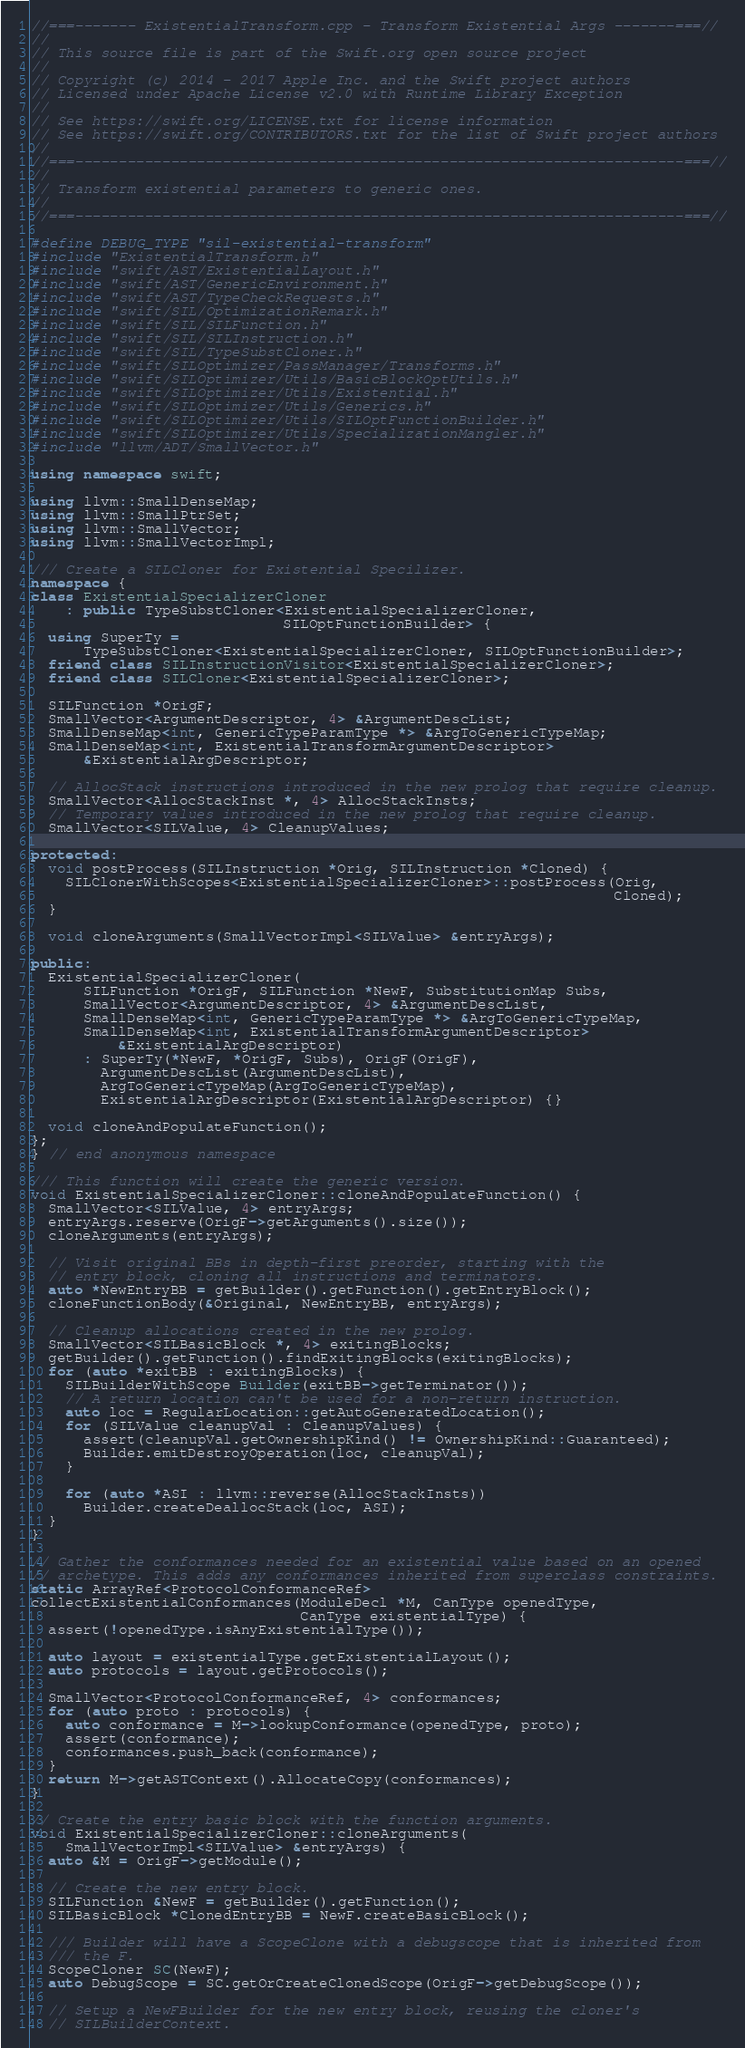<code> <loc_0><loc_0><loc_500><loc_500><_C++_>//===------- ExistentialTransform.cpp - Transform Existential Args -------===//
//
// This source file is part of the Swift.org open source project
//
// Copyright (c) 2014 - 2017 Apple Inc. and the Swift project authors
// Licensed under Apache License v2.0 with Runtime Library Exception
//
// See https://swift.org/LICENSE.txt for license information
// See https://swift.org/CONTRIBUTORS.txt for the list of Swift project authors
//
//===----------------------------------------------------------------------===//
//
// Transform existential parameters to generic ones.
//
//===----------------------------------------------------------------------===//

#define DEBUG_TYPE "sil-existential-transform"
#include "ExistentialTransform.h"
#include "swift/AST/ExistentialLayout.h"
#include "swift/AST/GenericEnvironment.h"
#include "swift/AST/TypeCheckRequests.h"
#include "swift/SIL/OptimizationRemark.h"
#include "swift/SIL/SILFunction.h"
#include "swift/SIL/SILInstruction.h"
#include "swift/SIL/TypeSubstCloner.h"
#include "swift/SILOptimizer/PassManager/Transforms.h"
#include "swift/SILOptimizer/Utils/BasicBlockOptUtils.h"
#include "swift/SILOptimizer/Utils/Existential.h"
#include "swift/SILOptimizer/Utils/Generics.h"
#include "swift/SILOptimizer/Utils/SILOptFunctionBuilder.h"
#include "swift/SILOptimizer/Utils/SpecializationMangler.h"
#include "llvm/ADT/SmallVector.h"

using namespace swift;

using llvm::SmallDenseMap;
using llvm::SmallPtrSet;
using llvm::SmallVector;
using llvm::SmallVectorImpl;

/// Create a SILCloner for Existential Specilizer.
namespace {
class ExistentialSpecializerCloner
    : public TypeSubstCloner<ExistentialSpecializerCloner,
                             SILOptFunctionBuilder> {
  using SuperTy =
      TypeSubstCloner<ExistentialSpecializerCloner, SILOptFunctionBuilder>;
  friend class SILInstructionVisitor<ExistentialSpecializerCloner>;
  friend class SILCloner<ExistentialSpecializerCloner>;

  SILFunction *OrigF;
  SmallVector<ArgumentDescriptor, 4> &ArgumentDescList;
  SmallDenseMap<int, GenericTypeParamType *> &ArgToGenericTypeMap;
  SmallDenseMap<int, ExistentialTransformArgumentDescriptor>
      &ExistentialArgDescriptor;

  // AllocStack instructions introduced in the new prolog that require cleanup.
  SmallVector<AllocStackInst *, 4> AllocStackInsts;
  // Temporary values introduced in the new prolog that require cleanup.
  SmallVector<SILValue, 4> CleanupValues;

protected:
  void postProcess(SILInstruction *Orig, SILInstruction *Cloned) {
    SILClonerWithScopes<ExistentialSpecializerCloner>::postProcess(Orig,
                                                                   Cloned);
  }

  void cloneArguments(SmallVectorImpl<SILValue> &entryArgs);

public:
  ExistentialSpecializerCloner(
      SILFunction *OrigF, SILFunction *NewF, SubstitutionMap Subs,
      SmallVector<ArgumentDescriptor, 4> &ArgumentDescList,
      SmallDenseMap<int, GenericTypeParamType *> &ArgToGenericTypeMap,
      SmallDenseMap<int, ExistentialTransformArgumentDescriptor>
          &ExistentialArgDescriptor)
      : SuperTy(*NewF, *OrigF, Subs), OrigF(OrigF),
        ArgumentDescList(ArgumentDescList),
        ArgToGenericTypeMap(ArgToGenericTypeMap),
        ExistentialArgDescriptor(ExistentialArgDescriptor) {}

  void cloneAndPopulateFunction();
};
} // end anonymous namespace

/// This function will create the generic version.
void ExistentialSpecializerCloner::cloneAndPopulateFunction() {
  SmallVector<SILValue, 4> entryArgs;
  entryArgs.reserve(OrigF->getArguments().size());
  cloneArguments(entryArgs);

  // Visit original BBs in depth-first preorder, starting with the
  // entry block, cloning all instructions and terminators.
  auto *NewEntryBB = getBuilder().getFunction().getEntryBlock();
  cloneFunctionBody(&Original, NewEntryBB, entryArgs);

  // Cleanup allocations created in the new prolog.
  SmallVector<SILBasicBlock *, 4> exitingBlocks;
  getBuilder().getFunction().findExitingBlocks(exitingBlocks);
  for (auto *exitBB : exitingBlocks) {
    SILBuilderWithScope Builder(exitBB->getTerminator());
    // A return location can't be used for a non-return instruction.
    auto loc = RegularLocation::getAutoGeneratedLocation();
    for (SILValue cleanupVal : CleanupValues) {
      assert(cleanupVal.getOwnershipKind() != OwnershipKind::Guaranteed);
      Builder.emitDestroyOperation(loc, cleanupVal);
    }

    for (auto *ASI : llvm::reverse(AllocStackInsts))
      Builder.createDeallocStack(loc, ASI);
  }
}

// Gather the conformances needed for an existential value based on an opened
// archetype. This adds any conformances inherited from superclass constraints.
static ArrayRef<ProtocolConformanceRef>
collectExistentialConformances(ModuleDecl *M, CanType openedType,
                               CanType existentialType) {
  assert(!openedType.isAnyExistentialType());

  auto layout = existentialType.getExistentialLayout();
  auto protocols = layout.getProtocols();

  SmallVector<ProtocolConformanceRef, 4> conformances;
  for (auto proto : protocols) {
    auto conformance = M->lookupConformance(openedType, proto);
    assert(conformance);
    conformances.push_back(conformance);
  }
  return M->getASTContext().AllocateCopy(conformances);
}

// Create the entry basic block with the function arguments.
void ExistentialSpecializerCloner::cloneArguments(
    SmallVectorImpl<SILValue> &entryArgs) {
  auto &M = OrigF->getModule();

  // Create the new entry block.
  SILFunction &NewF = getBuilder().getFunction();
  SILBasicBlock *ClonedEntryBB = NewF.createBasicBlock();

  /// Builder will have a ScopeClone with a debugscope that is inherited from
  /// the F.
  ScopeCloner SC(NewF);
  auto DebugScope = SC.getOrCreateClonedScope(OrigF->getDebugScope());

  // Setup a NewFBuilder for the new entry block, reusing the cloner's
  // SILBuilderContext.</code> 